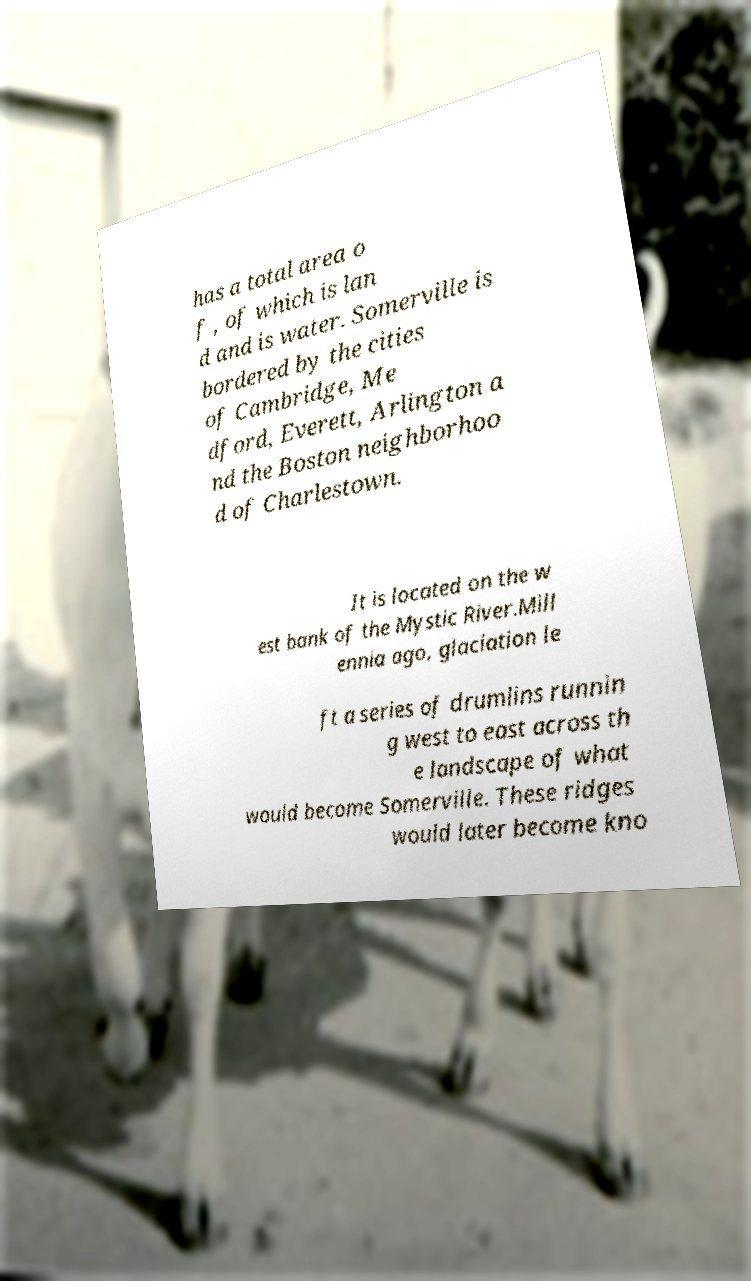Could you assist in decoding the text presented in this image and type it out clearly? has a total area o f , of which is lan d and is water. Somerville is bordered by the cities of Cambridge, Me dford, Everett, Arlington a nd the Boston neighborhoo d of Charlestown. It is located on the w est bank of the Mystic River.Mill ennia ago, glaciation le ft a series of drumlins runnin g west to east across th e landscape of what would become Somerville. These ridges would later become kno 